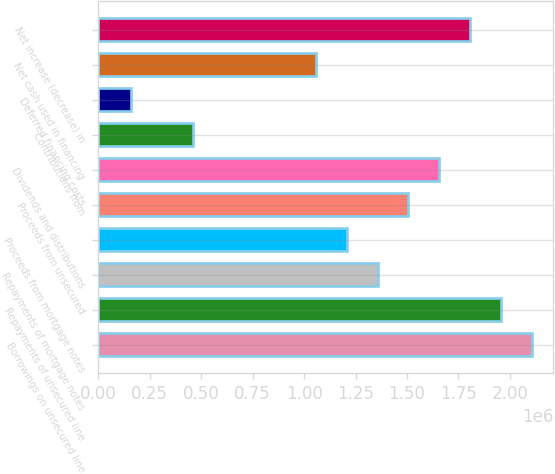Convert chart to OTSL. <chart><loc_0><loc_0><loc_500><loc_500><bar_chart><fcel>Borrowings on unsecured line<fcel>Repayments of unsecured line<fcel>Repayments of mortgage notes<fcel>Proceeds from mortgage notes<fcel>Proceeds from unsecured<fcel>Dividends and distributions<fcel>Contributions from<fcel>Deferred financing costs<fcel>Net cash used in financing<fcel>Net increase (decrease) in<nl><fcel>2.10533e+06<fcel>1.95573e+06<fcel>1.35732e+06<fcel>1.20772e+06<fcel>1.50692e+06<fcel>1.65652e+06<fcel>459710<fcel>160508<fcel>1.05812e+06<fcel>1.80612e+06<nl></chart> 